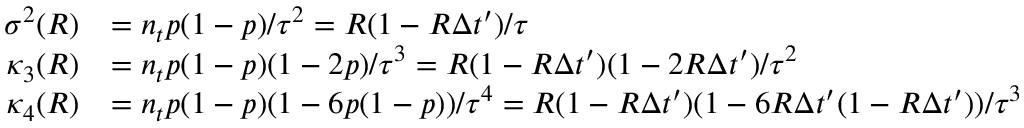<formula> <loc_0><loc_0><loc_500><loc_500>\begin{array} { r l } { \sigma ^ { 2 } ( R ) } & { = n _ { t } p ( 1 - p ) / \tau ^ { 2 } = R ( 1 - R \Delta t ^ { \prime } ) / \tau } \\ { \kappa _ { 3 } ( R ) } & { = n _ { t } p ( 1 - p ) ( 1 - 2 p ) / \tau ^ { 3 } = R ( 1 - R \Delta t ^ { \prime } ) ( 1 - 2 R \Delta t ^ { \prime } ) / \tau ^ { 2 } } \\ { \kappa _ { 4 } ( R ) } & { = n _ { t } p ( 1 - p ) ( 1 - 6 p ( 1 - p ) ) / \tau ^ { 4 } = R ( 1 - R \Delta t ^ { \prime } ) ( 1 - 6 R \Delta t ^ { \prime } ( 1 - R \Delta t ^ { \prime } ) ) / \tau ^ { 3 } } \end{array}</formula> 